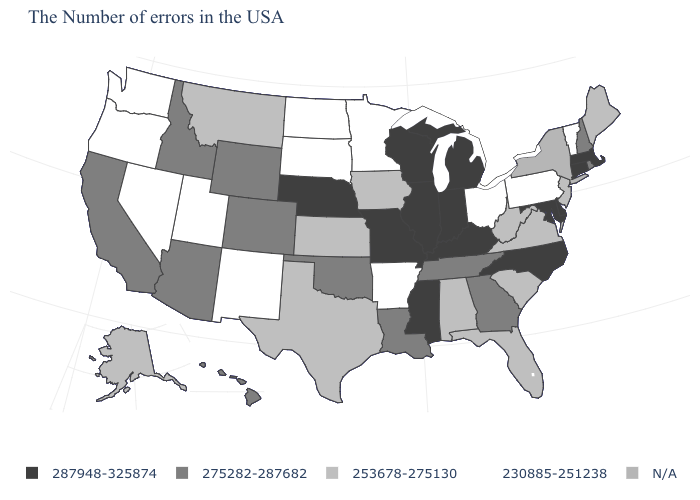What is the value of Minnesota?
Short answer required. 230885-251238. Among the states that border Rhode Island , which have the lowest value?
Write a very short answer. Massachusetts, Connecticut. What is the lowest value in the MidWest?
Answer briefly. 230885-251238. How many symbols are there in the legend?
Short answer required. 5. How many symbols are there in the legend?
Write a very short answer. 5. What is the lowest value in states that border Tennessee?
Concise answer only. 230885-251238. Which states have the lowest value in the USA?
Short answer required. Vermont, Pennsylvania, Ohio, Arkansas, Minnesota, South Dakota, North Dakota, New Mexico, Utah, Nevada, Washington, Oregon. Among the states that border Michigan , which have the highest value?
Write a very short answer. Indiana, Wisconsin. What is the lowest value in the Northeast?
Answer briefly. 230885-251238. Does West Virginia have the lowest value in the USA?
Be succinct. No. Name the states that have a value in the range 253678-275130?
Give a very brief answer. Maine, New Jersey, Virginia, South Carolina, West Virginia, Florida, Alabama, Iowa, Kansas, Texas, Montana, Alaska. Is the legend a continuous bar?
Short answer required. No. 